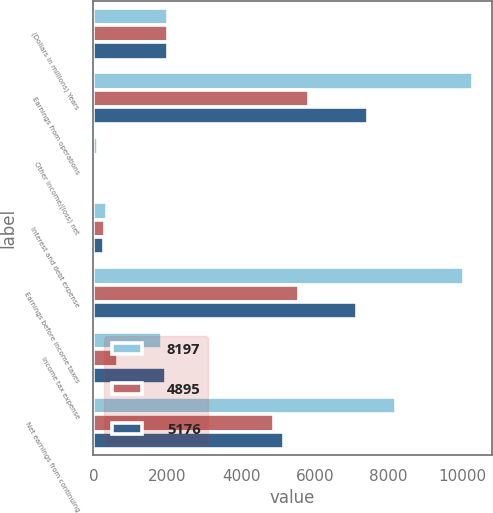Convert chart. <chart><loc_0><loc_0><loc_500><loc_500><stacked_bar_chart><ecel><fcel>(Dollars in millions) Years<fcel>Earnings from operations<fcel>Other income/(loss) net<fcel>Interest and debt expense<fcel>Earnings before income taxes<fcel>Income tax expense<fcel>Net earnings from continuing<nl><fcel>8197<fcel>2017<fcel>10278<fcel>129<fcel>360<fcel>10047<fcel>1850<fcel>8197<nl><fcel>4895<fcel>2016<fcel>5834<fcel>40<fcel>306<fcel>5568<fcel>673<fcel>4895<nl><fcel>5176<fcel>2015<fcel>7443<fcel>13<fcel>275<fcel>7155<fcel>1979<fcel>5176<nl></chart> 